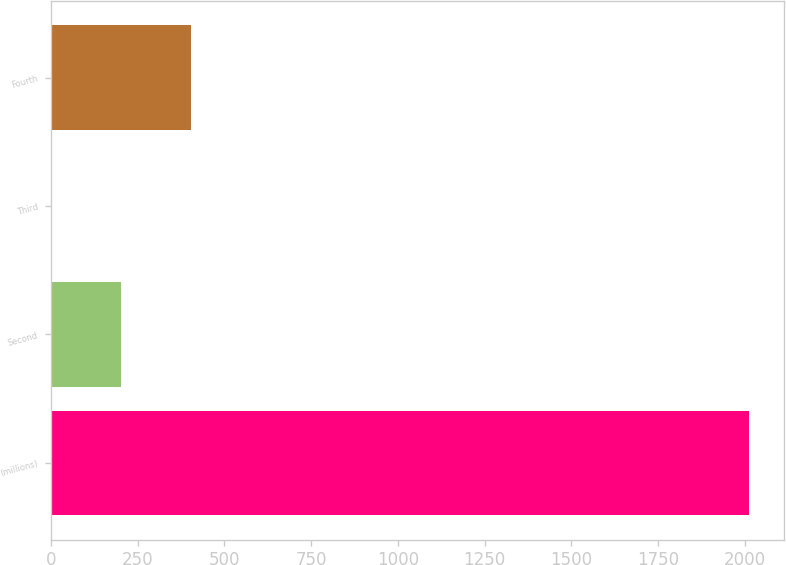Convert chart to OTSL. <chart><loc_0><loc_0><loc_500><loc_500><bar_chart><fcel>(millions)<fcel>Second<fcel>Third<fcel>Fourth<nl><fcel>2013<fcel>202.11<fcel>0.9<fcel>403.32<nl></chart> 